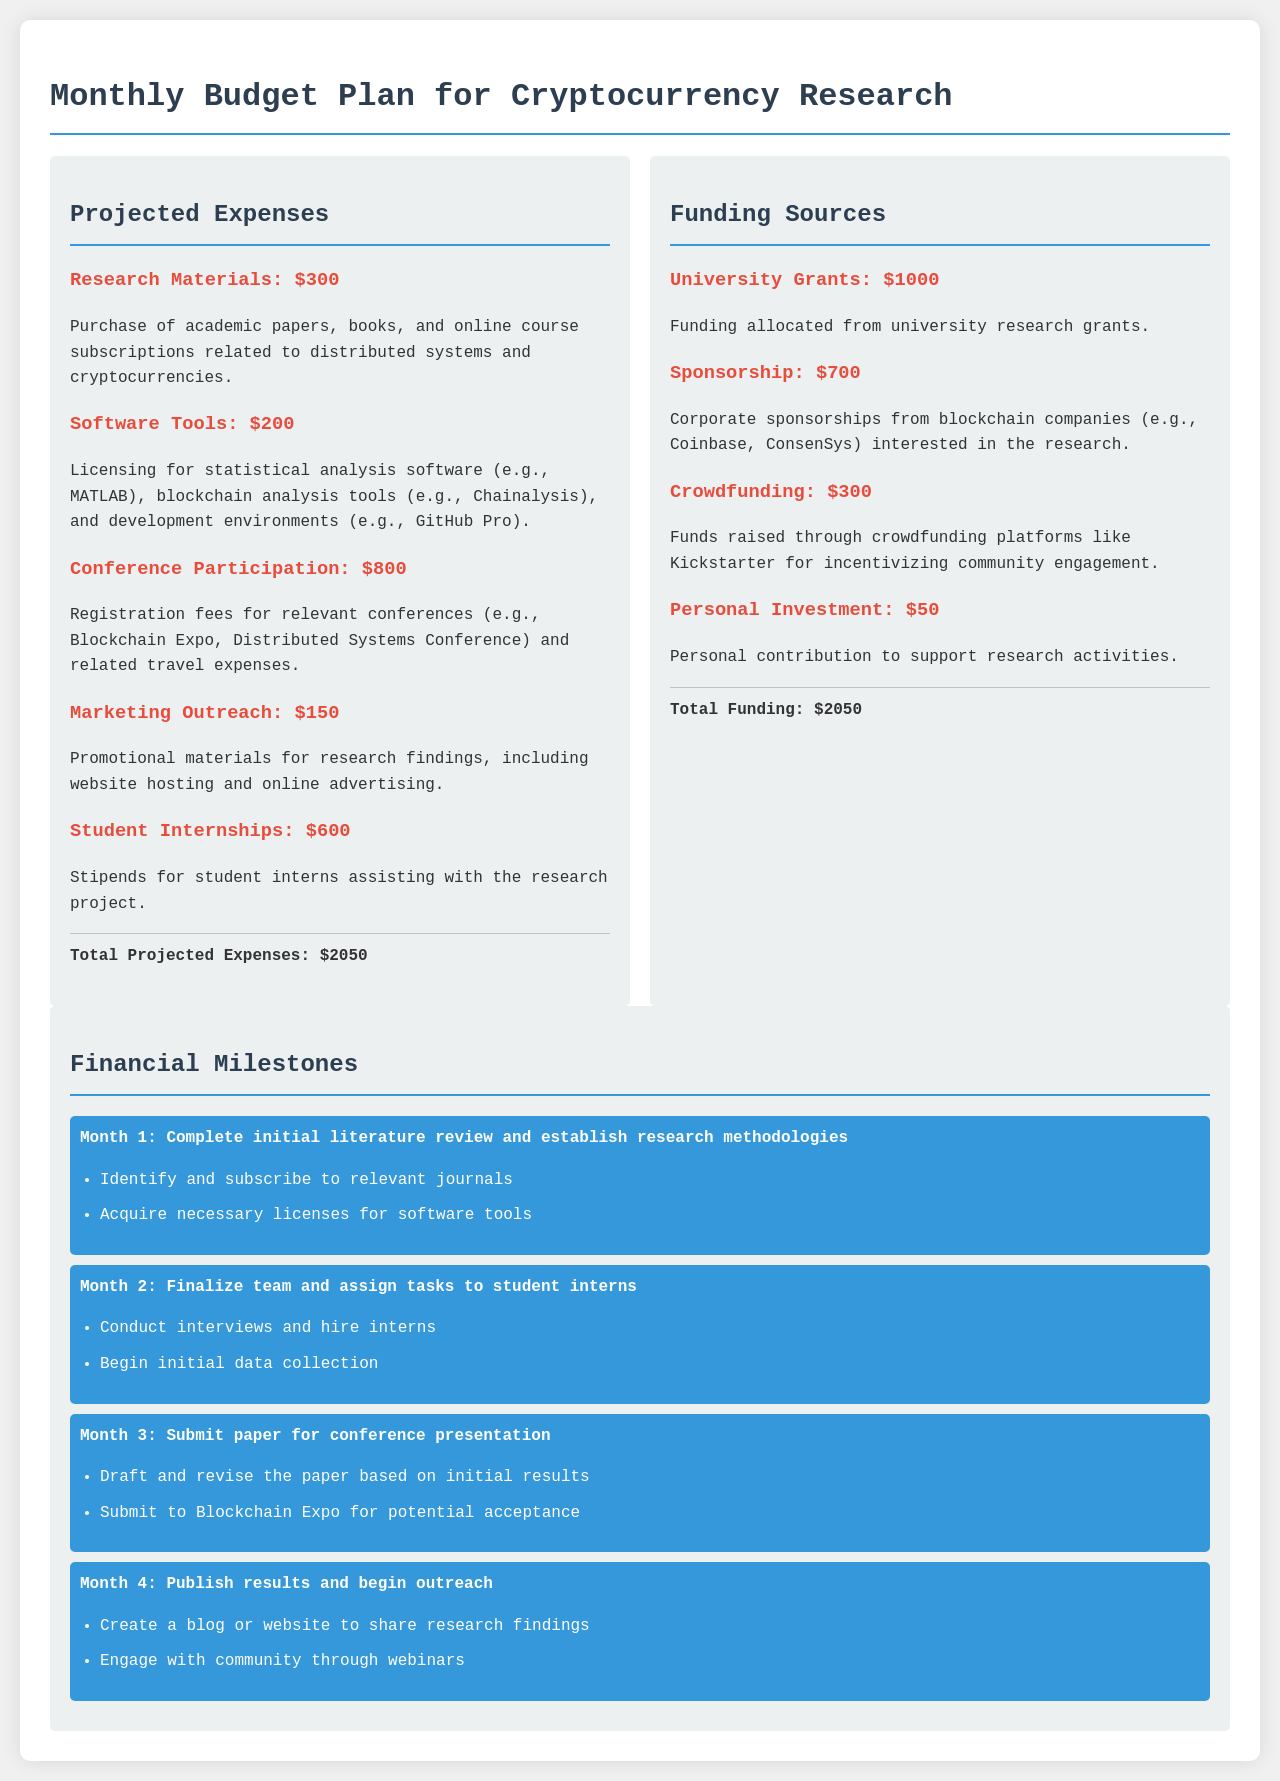What are the projected expenses for research materials? The document lists the projected expenses for research materials as $300.
Answer: $300 What is the total funding amount? The total funding is obtained by summarizing all funding sources listed in the document, which collectively amounts to $2050.
Answer: $2050 How much is allocated for conference participation? The document specifies that the amount allocated for conference participation is $800.
Answer: $800 What is one of the tasks for Month 2? The document notes that one of the tasks for Month 2 is to conduct interviews and hire interns.
Answer: Conduct interviews and hire interns What is the total projected expenses? The document states the total projected expenses as $2050, matching the total funding.
Answer: $2050 What type of software tools are included in the expenses? The expenses include licensing for statistical analysis software and blockchain analysis tools.
Answer: Statistical analysis software and blockchain analysis tools What are the financial milestones? The document outlines several milestones, including completing the initial literature review and establishing research methodologies.
Answer: Complete initial literature review and establish research methodologies What is the funding source that provides $1000? The document identifies university grants as the source providing $1000.
Answer: University Grants How many student internships are planned? The document has projected expenses including stipends for student interns, explicitly mentioning $600 for this purpose.
Answer: $600 